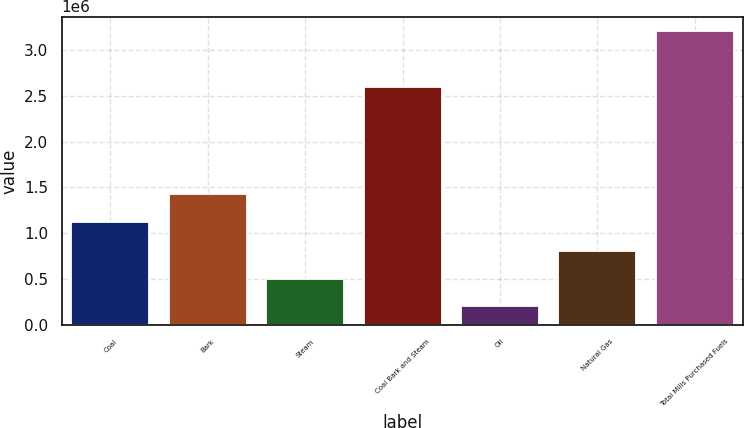Convert chart to OTSL. <chart><loc_0><loc_0><loc_500><loc_500><bar_chart><fcel>Coal<fcel>Bark<fcel>Steam<fcel>Coal Bark and Steam<fcel>Oil<fcel>Natural Gas<fcel>Total Mills Purchased Fuels<nl><fcel>1.12359e+06<fcel>1.42339e+06<fcel>503627<fcel>2.58967e+06<fcel>203827<fcel>803426<fcel>3.20182e+06<nl></chart> 